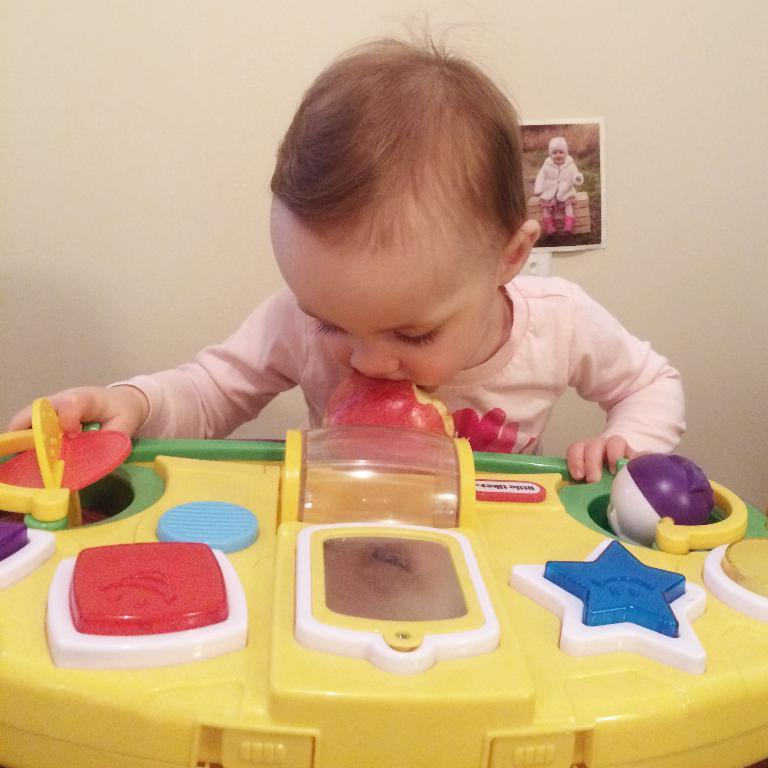What is the main subject of the image? The main subject of the image is a kid. What is the kid doing in the image? The kid is playing with a toy. Where is the toy located in relation to the kid? The toy is in the kid's mouth. What can be seen in the background of the image? There is a wall in the background of the image, and there is a photo on the wall. What type of chicken is visible in the image? There is no chicken present in the image. Can you describe the rabbit playing with the kid in the image? There is no rabbit present in the image; the kid is playing with a toy. 